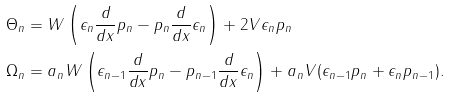<formula> <loc_0><loc_0><loc_500><loc_500>& \Theta _ { n } = W \left ( \epsilon _ { n } \frac { d } { d x } p _ { n } - p _ { n } \frac { d } { d x } \epsilon _ { n } \right ) + 2 V \epsilon _ { n } p _ { n } \\ & \Omega _ { n } = a _ { n } W \left ( \epsilon _ { n - 1 } \frac { d } { d x } p _ { n } - p _ { n - 1 } \frac { d } { d x } \epsilon _ { n } \right ) + a _ { n } V ( \epsilon _ { n - 1 } p _ { n } + \epsilon _ { n } p _ { n - 1 } ) .</formula> 